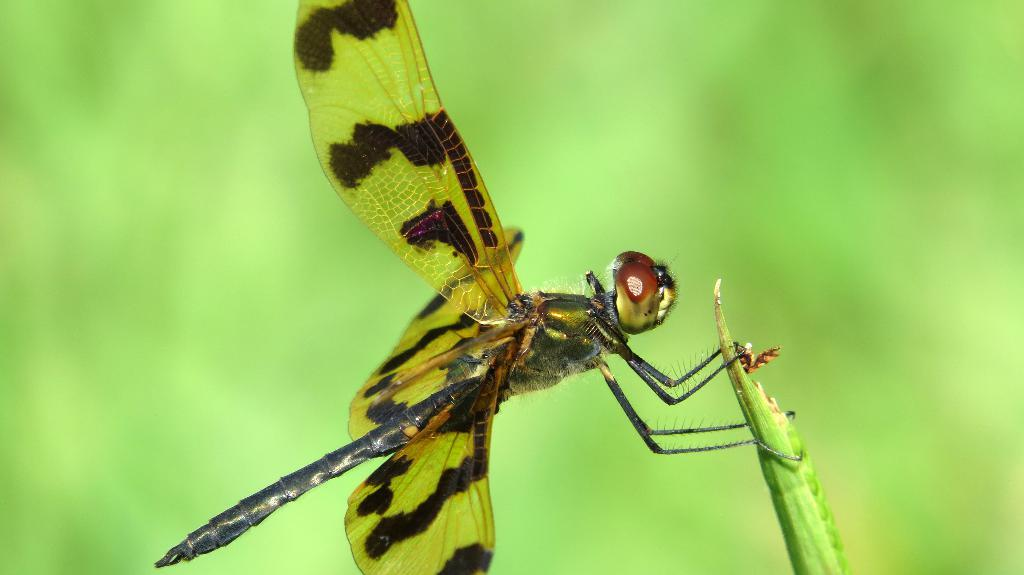What is the main subject of the picture? The main subject of the picture is a dragonfly. Where is the dragonfly located in the image? The dragonfly is standing on a plant. What colors are present on the dragonfly's wings? The wings of the dragonfly are green and brown. What is the color of the background in the picture? There is a green background in the picture. What type of fuel is being used by the dragonfly in the image? There is no indication in the image that the dragonfly is using any type of fuel, as dragonflies are insects that fly using their wings. 